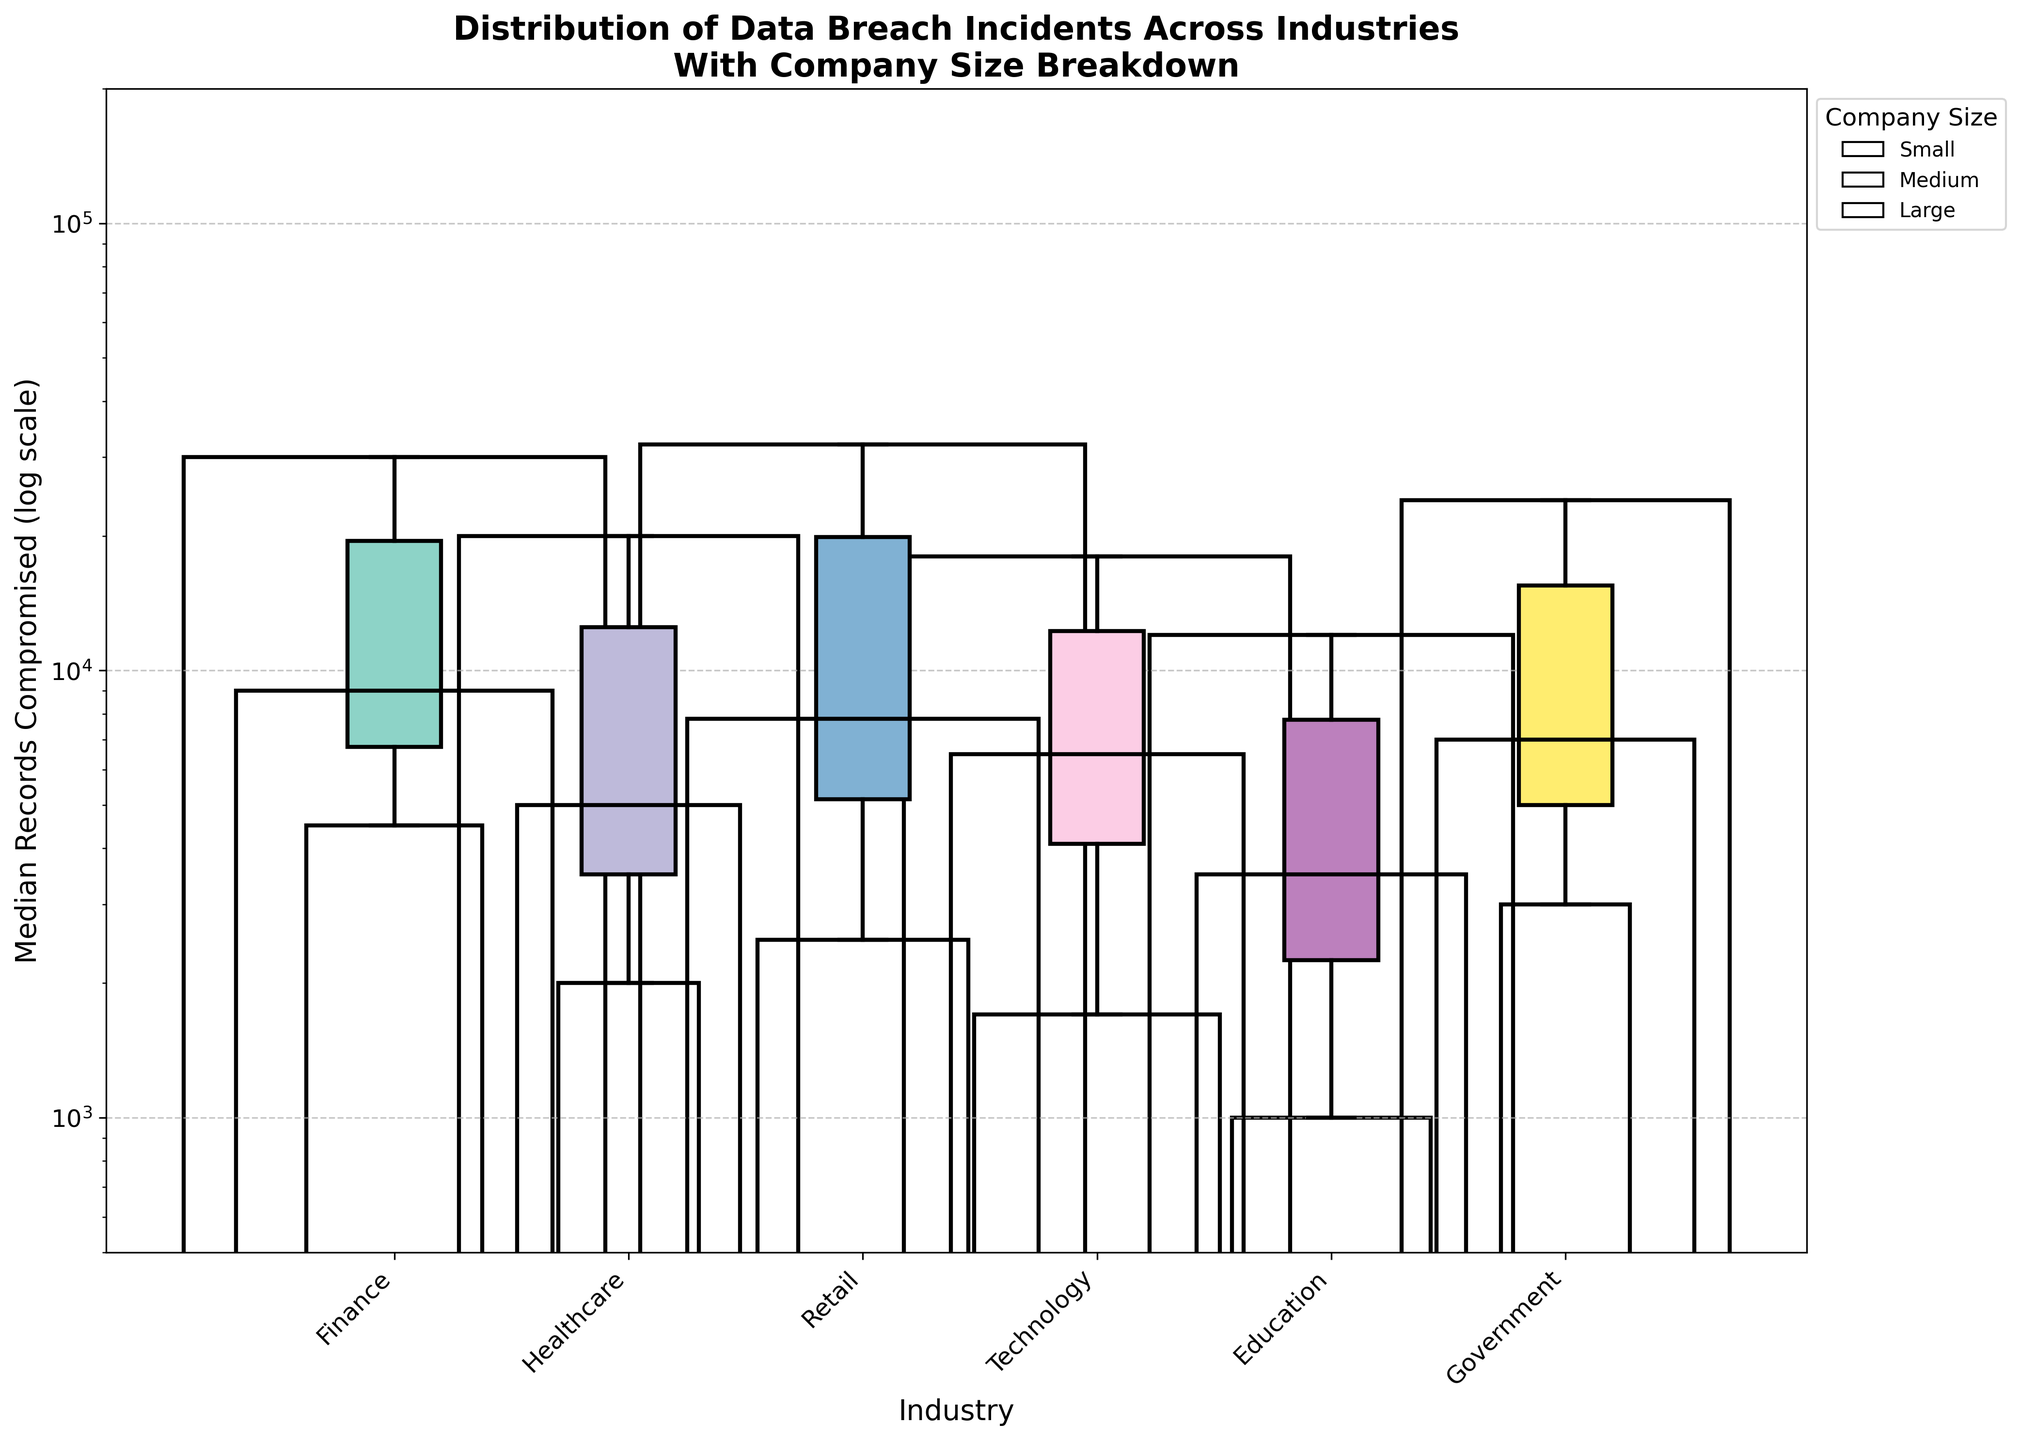What is the title of the figure? The title is at the top of the figure and is usually the most prominent text. The title reads "Distribution of Data Breach Incidents Across Industries With Company Size Breakdown."
Answer: Distribution of Data Breach Incidents Across Industries With Company Size Breakdown Which industry has the highest median records compromised for large companies? To determine the highest median records compromised, we look at the median value for the large company size across all industries. Finance has the highest median value of 30,000.
Answer: Finance What is the maximum number of records compromised for small companies in the Retail industry? To find this, locate the small company category for Retail in the data, which lists the maximum records compromised as 9,200.
Answer: 9,200 Compare the number of incidents between medium-sized companies in the Healthcare and Education industries. Which has more incidents? Check the number of incidents for medium-sized companies in both Healthcare (19) and Education (23). Education has more incidents.
Answer: Education Are there more incidents in large companies or small companies in the Government sector? Compare the number of incidents in the Government sector for large companies (28) and small companies (11). There are more incidents in large companies.
Answer: Large companies What is the width of the rectangle representing small companies in the Technology industry, and why is it significant? The width is proportional to the number of incidents. Small Technology companies have 21 incidents, making the width 21/10 = 2.1 units.
Answer: 2.1 units Which industry has the smallest median records compromised for small companies, and what is the value? Look at median values for small companies across all industries. Education has the smallest median value at 1,000.
Answer: Education, 1,000 On which axis is the log scale applied? The y-axis represents "Median Records Compromised" and the values appear in powers of ten, indicating the log scale.
Answer: y-axis How many times more incidents do medium-sized Finance companies have compared to small-sized Finance companies? Divide the number of incidents for medium-sized Finance companies (27) by small-sized Finance companies (15). 27 / 15 = 1.8 times.
Answer: 1.8 times Between which industries is the difference in median records compromised for medium-sized companies the largest? Compare median values for medium-sized companies. The largest difference is between Finance (9,000) and Education (3,500), giving a difference of 5,500 records.
Answer: Finance and Education 